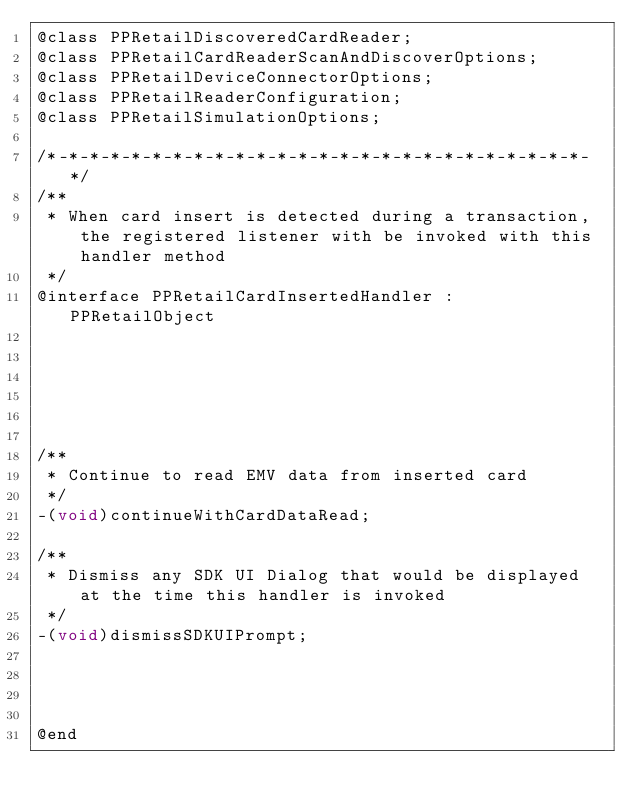<code> <loc_0><loc_0><loc_500><loc_500><_C_>@class PPRetailDiscoveredCardReader;
@class PPRetailCardReaderScanAndDiscoverOptions;
@class PPRetailDeviceConnectorOptions;
@class PPRetailReaderConfiguration;
@class PPRetailSimulationOptions;

/*-*-*-*-*-*-*-*-*-*-*-*-*-*-*-*-*-*-*-*-*-*-*-*-*-*-*/
/**
 * When card insert is detected during a transaction, the registered listener with be invoked with this handler method
 */
@interface PPRetailCardInsertedHandler : PPRetailObject






/**
 * Continue to read EMV data from inserted card
 */
-(void)continueWithCardDataRead;

/**
 * Dismiss any SDK UI Dialog that would be displayed at the time this handler is invoked
 */
-(void)dismissSDKUIPrompt;




@end
</code> 